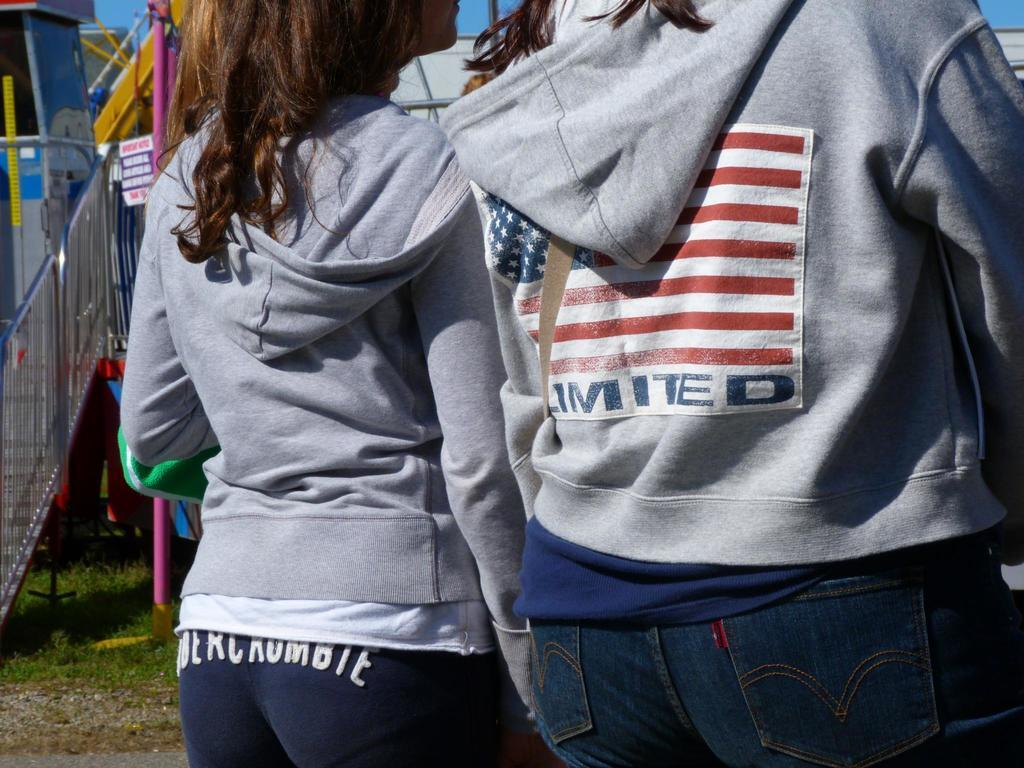How many people are in the image? There are two people standing in the image. What are the people wearing? The people are wearing jerkins and trousers. What architectural feature can be seen in the image? There are stairs in the image. What is the pole in the image used for? The purpose of the pole in the image is not specified, but it could be a support structure or a decorative element. What type of vegetation is present in the image? There is grass in the image. What year is the father mentioned in the image? There is no mention of a father or any specific year in the image. 